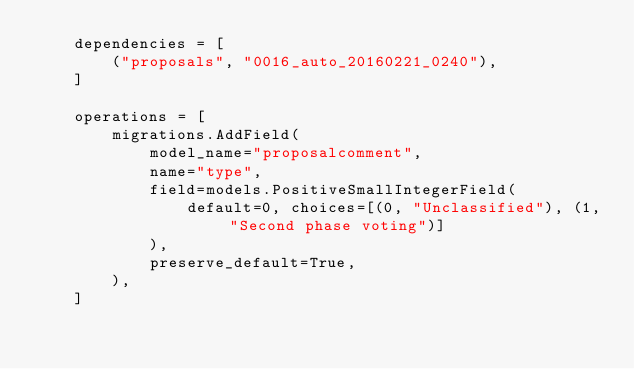Convert code to text. <code><loc_0><loc_0><loc_500><loc_500><_Python_>    dependencies = [
        ("proposals", "0016_auto_20160221_0240"),
    ]

    operations = [
        migrations.AddField(
            model_name="proposalcomment",
            name="type",
            field=models.PositiveSmallIntegerField(
                default=0, choices=[(0, "Unclassified"), (1, "Second phase voting")]
            ),
            preserve_default=True,
        ),
    ]
</code> 